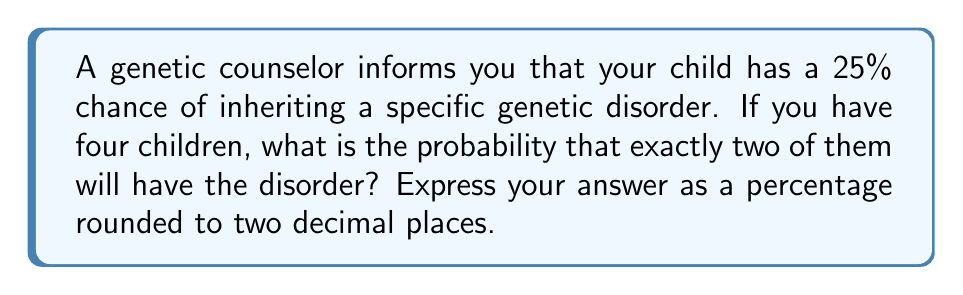Can you solve this math problem? To solve this problem, we'll use the binomial probability formula, as this is a situation with a fixed number of independent trials (4 children) with two possible outcomes for each (having the disorder or not).

1) The probability of having the disorder is $p = 0.25$ (25%)
2) The probability of not having the disorder is $q = 1 - p = 0.75$ (75%)
3) We want exactly 2 out of 4 children to have the disorder

The binomial probability formula is:

$$P(X = k) = \binom{n}{k} p^k q^{n-k}$$

Where:
$n$ = number of trials (4 children)
$k$ = number of successes (2 children with the disorder)
$p$ = probability of success on each trial (0.25)
$q$ = probability of failure on each trial (0.75)

Let's calculate:

$$P(X = 2) = \binom{4}{2} (0.25)^2 (0.75)^{4-2}$$

$$= 6 \cdot (0.25)^2 \cdot (0.75)^2$$

$$= 6 \cdot 0.0625 \cdot 0.5625$$

$$= 6 \cdot 0.0351562500$$

$$= 0.2109375$$

Converting to a percentage and rounding to two decimal places:

$0.2109375 \cdot 100 = 21.09375\%$

Rounded to two decimal places: $21.09\%$
Answer: 21.09% 